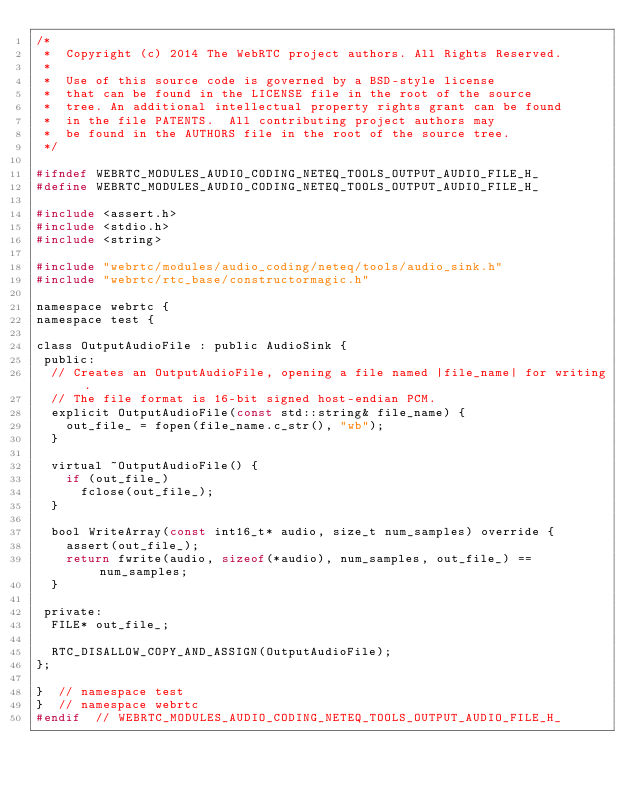Convert code to text. <code><loc_0><loc_0><loc_500><loc_500><_C_>/*
 *  Copyright (c) 2014 The WebRTC project authors. All Rights Reserved.
 *
 *  Use of this source code is governed by a BSD-style license
 *  that can be found in the LICENSE file in the root of the source
 *  tree. An additional intellectual property rights grant can be found
 *  in the file PATENTS.  All contributing project authors may
 *  be found in the AUTHORS file in the root of the source tree.
 */

#ifndef WEBRTC_MODULES_AUDIO_CODING_NETEQ_TOOLS_OUTPUT_AUDIO_FILE_H_
#define WEBRTC_MODULES_AUDIO_CODING_NETEQ_TOOLS_OUTPUT_AUDIO_FILE_H_

#include <assert.h>
#include <stdio.h>
#include <string>

#include "webrtc/modules/audio_coding/neteq/tools/audio_sink.h"
#include "webrtc/rtc_base/constructormagic.h"

namespace webrtc {
namespace test {

class OutputAudioFile : public AudioSink {
 public:
  // Creates an OutputAudioFile, opening a file named |file_name| for writing.
  // The file format is 16-bit signed host-endian PCM.
  explicit OutputAudioFile(const std::string& file_name) {
    out_file_ = fopen(file_name.c_str(), "wb");
  }

  virtual ~OutputAudioFile() {
    if (out_file_)
      fclose(out_file_);
  }

  bool WriteArray(const int16_t* audio, size_t num_samples) override {
    assert(out_file_);
    return fwrite(audio, sizeof(*audio), num_samples, out_file_) == num_samples;
  }

 private:
  FILE* out_file_;

  RTC_DISALLOW_COPY_AND_ASSIGN(OutputAudioFile);
};

}  // namespace test
}  // namespace webrtc
#endif  // WEBRTC_MODULES_AUDIO_CODING_NETEQ_TOOLS_OUTPUT_AUDIO_FILE_H_
</code> 